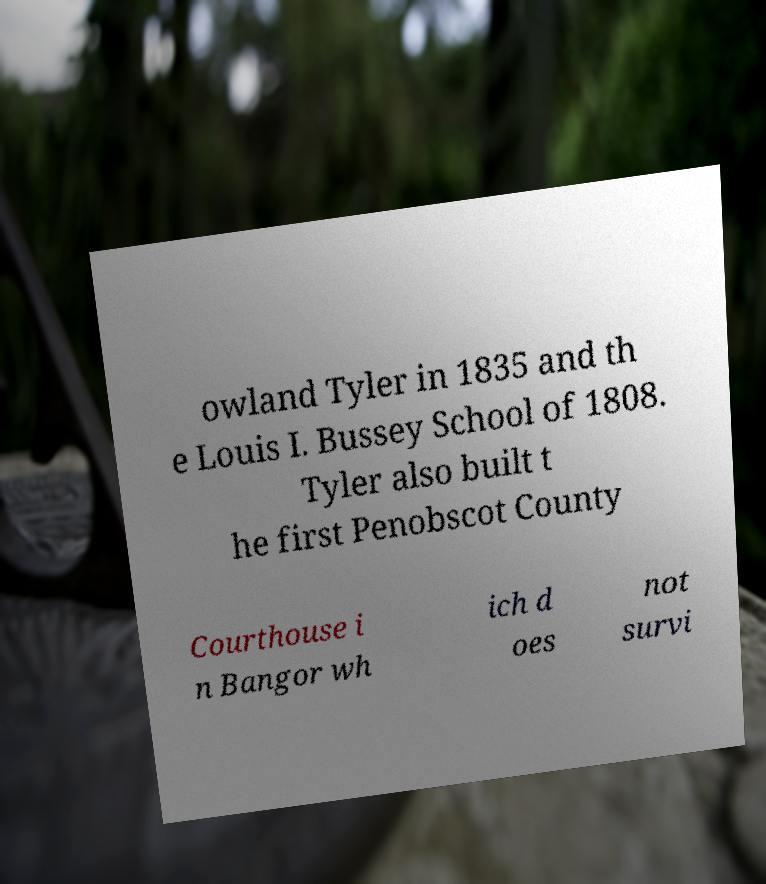Can you read and provide the text displayed in the image?This photo seems to have some interesting text. Can you extract and type it out for me? owland Tyler in 1835 and th e Louis I. Bussey School of 1808. Tyler also built t he first Penobscot County Courthouse i n Bangor wh ich d oes not survi 